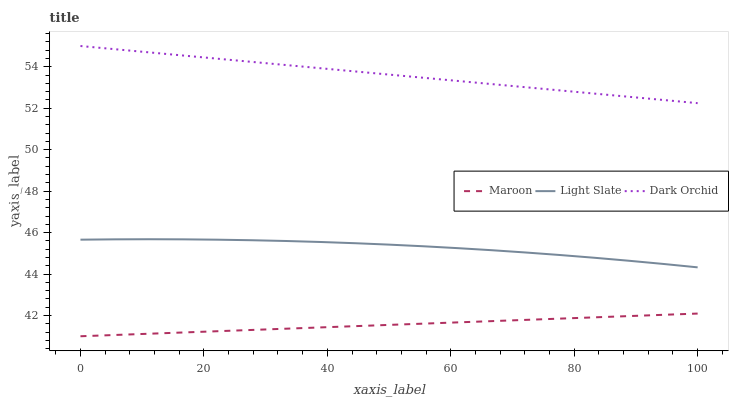Does Maroon have the minimum area under the curve?
Answer yes or no. Yes. Does Dark Orchid have the maximum area under the curve?
Answer yes or no. Yes. Does Dark Orchid have the minimum area under the curve?
Answer yes or no. No. Does Maroon have the maximum area under the curve?
Answer yes or no. No. Is Maroon the smoothest?
Answer yes or no. Yes. Is Light Slate the roughest?
Answer yes or no. Yes. Is Dark Orchid the smoothest?
Answer yes or no. No. Is Dark Orchid the roughest?
Answer yes or no. No. Does Maroon have the lowest value?
Answer yes or no. Yes. Does Dark Orchid have the lowest value?
Answer yes or no. No. Does Dark Orchid have the highest value?
Answer yes or no. Yes. Does Maroon have the highest value?
Answer yes or no. No. Is Maroon less than Light Slate?
Answer yes or no. Yes. Is Dark Orchid greater than Maroon?
Answer yes or no. Yes. Does Maroon intersect Light Slate?
Answer yes or no. No. 